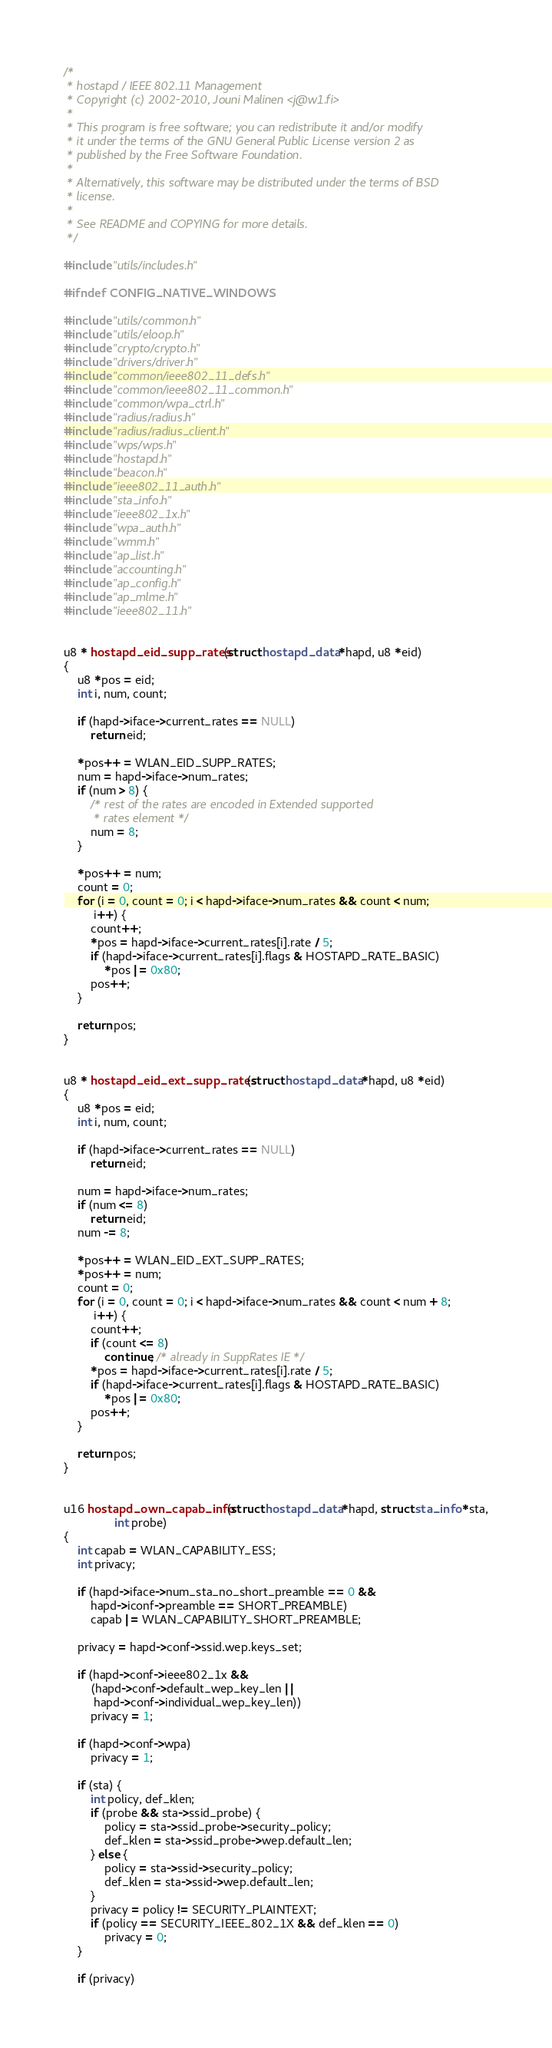<code> <loc_0><loc_0><loc_500><loc_500><_C_>/*
 * hostapd / IEEE 802.11 Management
 * Copyright (c) 2002-2010, Jouni Malinen <j@w1.fi>
 *
 * This program is free software; you can redistribute it and/or modify
 * it under the terms of the GNU General Public License version 2 as
 * published by the Free Software Foundation.
 *
 * Alternatively, this software may be distributed under the terms of BSD
 * license.
 *
 * See README and COPYING for more details.
 */

#include "utils/includes.h"

#ifndef CONFIG_NATIVE_WINDOWS

#include "utils/common.h"
#include "utils/eloop.h"
#include "crypto/crypto.h"
#include "drivers/driver.h"
#include "common/ieee802_11_defs.h"
#include "common/ieee802_11_common.h"
#include "common/wpa_ctrl.h"
#include "radius/radius.h"
#include "radius/radius_client.h"
#include "wps/wps.h"
#include "hostapd.h"
#include "beacon.h"
#include "ieee802_11_auth.h"
#include "sta_info.h"
#include "ieee802_1x.h"
#include "wpa_auth.h"
#include "wmm.h"
#include "ap_list.h"
#include "accounting.h"
#include "ap_config.h"
#include "ap_mlme.h"
#include "ieee802_11.h"


u8 * hostapd_eid_supp_rates(struct hostapd_data *hapd, u8 *eid)
{
	u8 *pos = eid;
	int i, num, count;

	if (hapd->iface->current_rates == NULL)
		return eid;

	*pos++ = WLAN_EID_SUPP_RATES;
	num = hapd->iface->num_rates;
	if (num > 8) {
		/* rest of the rates are encoded in Extended supported
		 * rates element */
		num = 8;
	}

	*pos++ = num;
	count = 0;
	for (i = 0, count = 0; i < hapd->iface->num_rates && count < num;
	     i++) {
		count++;
		*pos = hapd->iface->current_rates[i].rate / 5;
		if (hapd->iface->current_rates[i].flags & HOSTAPD_RATE_BASIC)
			*pos |= 0x80;
		pos++;
	}

	return pos;
}


u8 * hostapd_eid_ext_supp_rates(struct hostapd_data *hapd, u8 *eid)
{
	u8 *pos = eid;
	int i, num, count;

	if (hapd->iface->current_rates == NULL)
		return eid;

	num = hapd->iface->num_rates;
	if (num <= 8)
		return eid;
	num -= 8;

	*pos++ = WLAN_EID_EXT_SUPP_RATES;
	*pos++ = num;
	count = 0;
	for (i = 0, count = 0; i < hapd->iface->num_rates && count < num + 8;
	     i++) {
		count++;
		if (count <= 8)
			continue; /* already in SuppRates IE */
		*pos = hapd->iface->current_rates[i].rate / 5;
		if (hapd->iface->current_rates[i].flags & HOSTAPD_RATE_BASIC)
			*pos |= 0x80;
		pos++;
	}

	return pos;
}


u16 hostapd_own_capab_info(struct hostapd_data *hapd, struct sta_info *sta,
			   int probe)
{
	int capab = WLAN_CAPABILITY_ESS;
	int privacy;

	if (hapd->iface->num_sta_no_short_preamble == 0 &&
	    hapd->iconf->preamble == SHORT_PREAMBLE)
		capab |= WLAN_CAPABILITY_SHORT_PREAMBLE;

	privacy = hapd->conf->ssid.wep.keys_set;

	if (hapd->conf->ieee802_1x &&
	    (hapd->conf->default_wep_key_len ||
	     hapd->conf->individual_wep_key_len))
		privacy = 1;

	if (hapd->conf->wpa)
		privacy = 1;

	if (sta) {
		int policy, def_klen;
		if (probe && sta->ssid_probe) {
			policy = sta->ssid_probe->security_policy;
			def_klen = sta->ssid_probe->wep.default_len;
		} else {
			policy = sta->ssid->security_policy;
			def_klen = sta->ssid->wep.default_len;
		}
		privacy = policy != SECURITY_PLAINTEXT;
		if (policy == SECURITY_IEEE_802_1X && def_klen == 0)
			privacy = 0;
	}

	if (privacy)</code> 